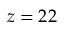Convert formula to latex. <formula><loc_0><loc_0><loc_500><loc_500>z = 2 2</formula> 